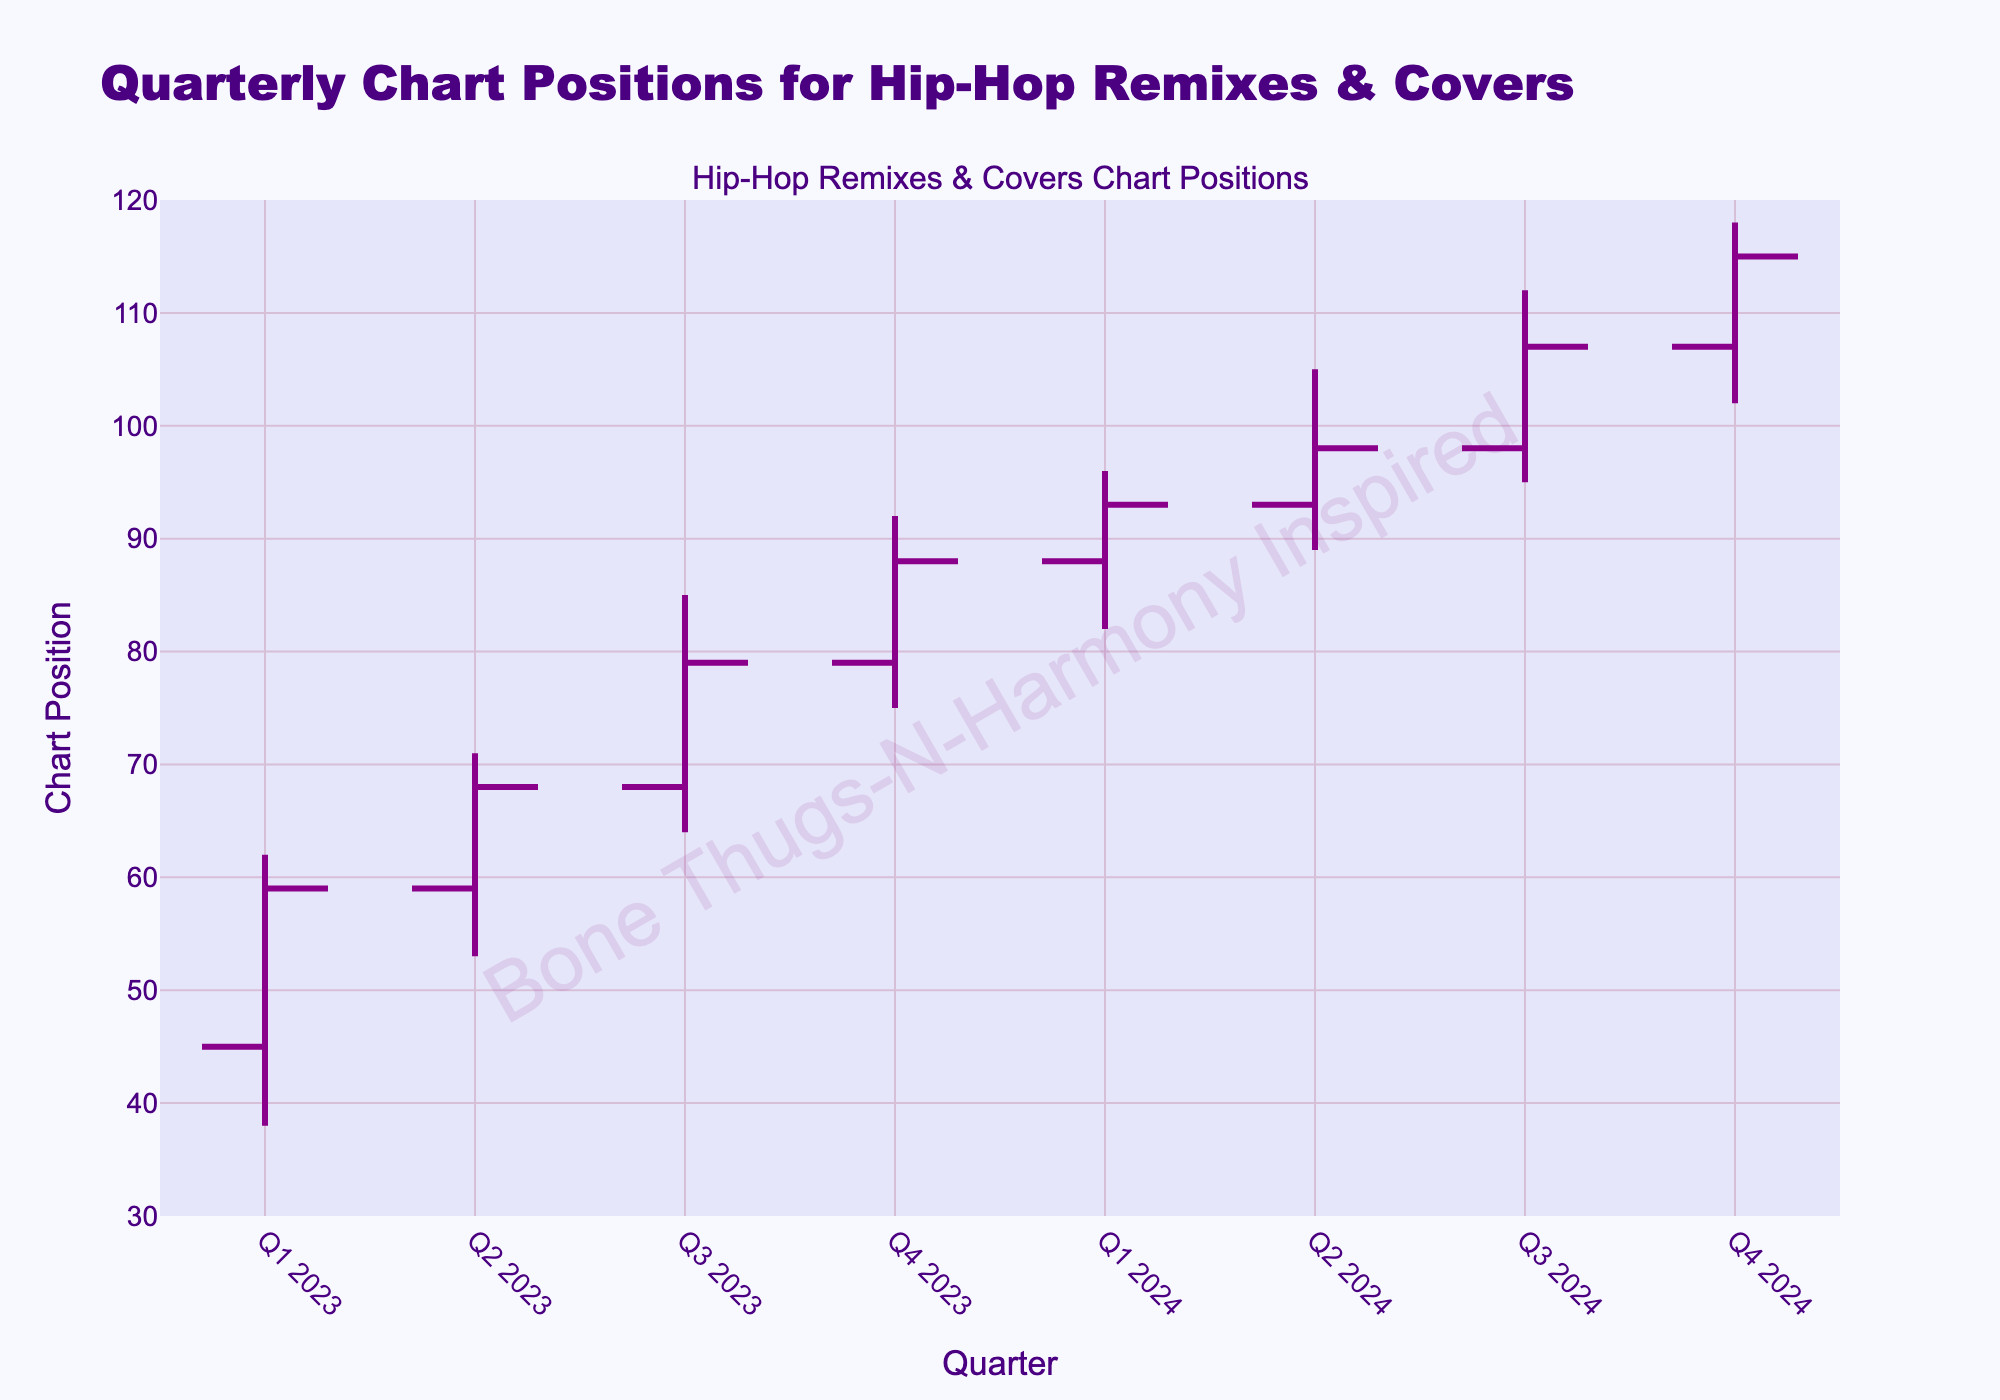What's the title of the figure? The title of the figure is prominently displayed at the top center.
Answer: Quarterly Chart Positions for Hip-Hop Remixes & Covers What are the colors used for increasing and decreasing lines? By examining the lines in the OHLC chart, you can see the colors used for increasing and decreasing trends. The increasing lines are dark magenta and the decreasing lines are indigo.
Answer: Dark magenta and indigo How has the chart position trend moved from Q1 2023 to Q4 2024? The trend can be traced from the opening of Q1 2023 till the closing of Q4 2024, showing a general upward movement across the quarters. Open starts at 45 in Q1 2023 and Close ends at 115 in Q4 2024.
Answer: Upward trend Which quarter had the highest high value and what was it? The High values for each quarter need to be compared. The High value of Q4 2024 is the maximum at 118.
Answer: Q4 2024, 118 From which quarter to which quarter did the chart positions consistently increase without any decrease? By reviewing the Close values, you can see that they consistently increase from Q1 2023 (59) to Q4 2024 (115) without any decreases.
Answer: Q1 2023 to Q4 2024 What was the difference between the highest high and lowest low values across all quarters? The highest high is 118 (Q4 2024) and the lowest low is 38 (Q1 2023). The difference is calculated as 118 - 38.
Answer: 80 Which quarter had the biggest range between its high and low values? To find this, calculate the range (High minus Low) for each quarter and compare. Q4 2024 has the biggest range of 118 - 102, which equals 16.
Answer: Q4 2024 In which quarter was the closing position the highest? By examining the Close column, you can identify that Q4 2024 has the highest closing position at 115.
Answer: Q4 2024 Which quarter showed the smallest change in chart position from open to close? Calculate the difference between Open and Close for each quarter to find the smallest change. Q2 2023 shows the smallest change with only 9 (68 - 59).
Answer: Q2 2023 